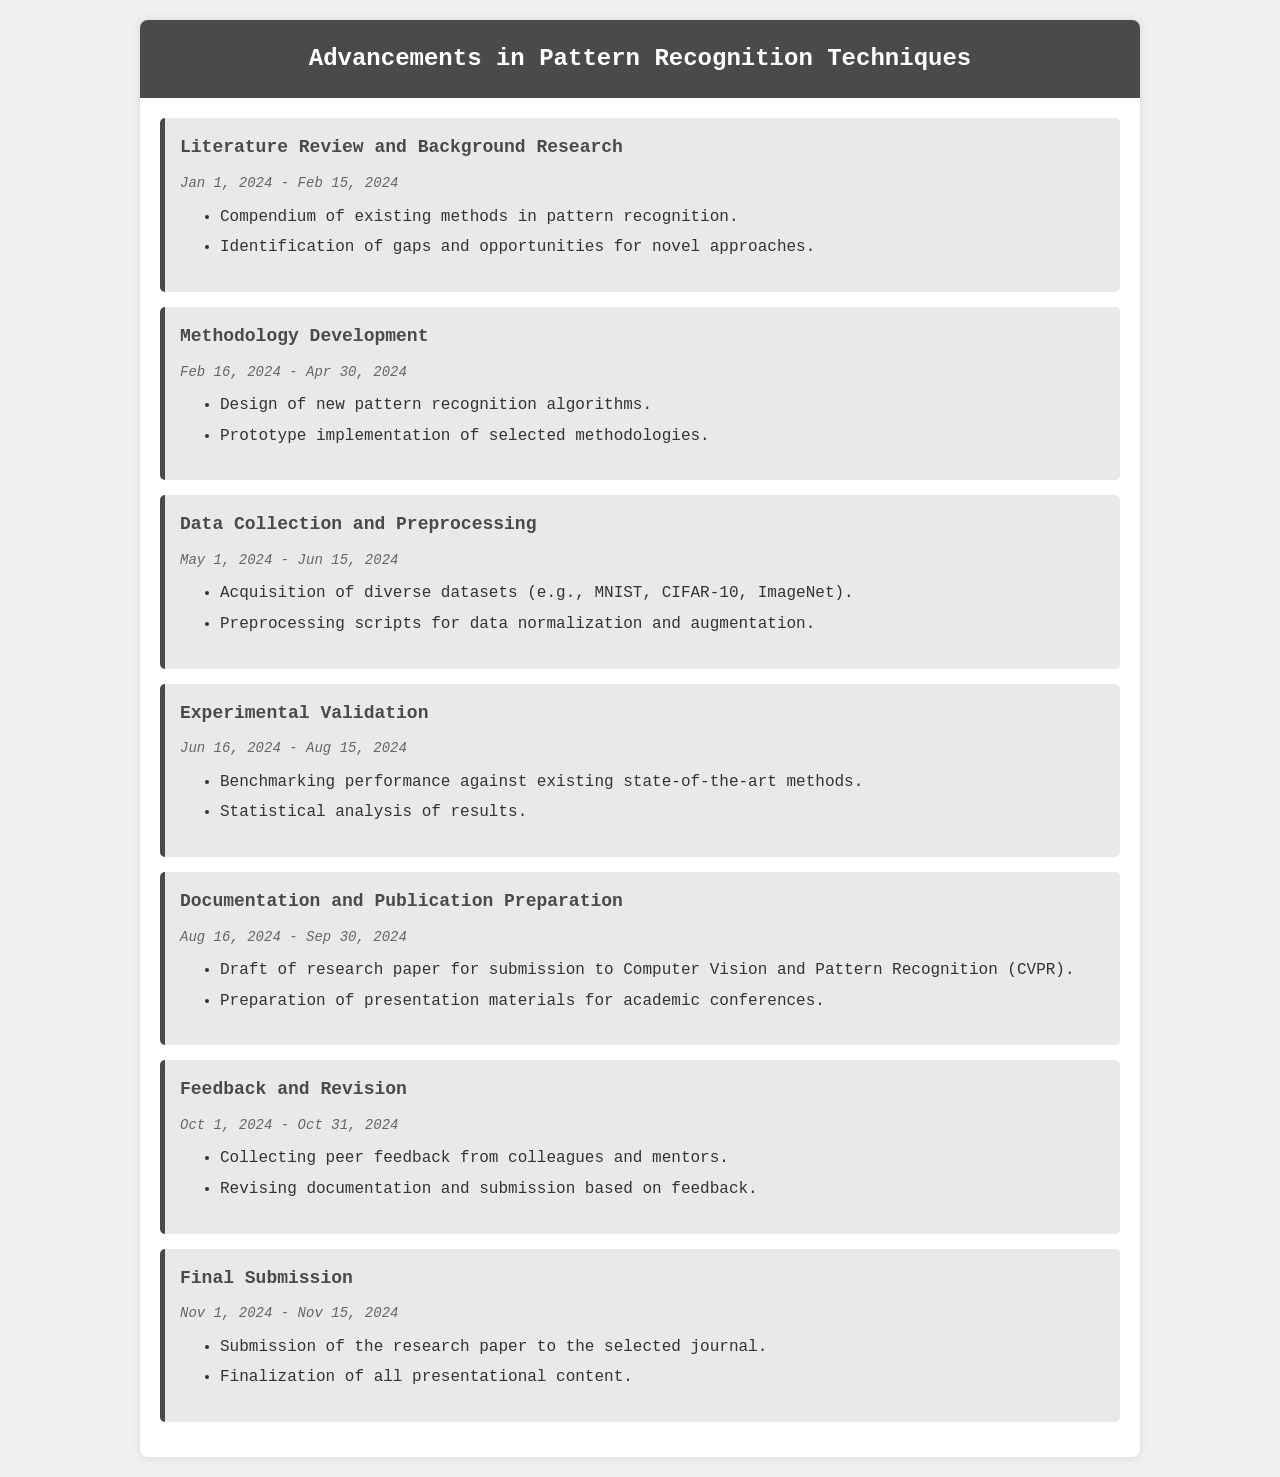What is the title of the project? The title of the project is prominently displayed at the top of the document.
Answer: Advancements in Pattern Recognition Techniques What is the duration of the Literature Review phase? The duration is indicated by the start and end dates shown in that section of the document.
Answer: Jan 1, 2024 - Feb 15, 2024 What is a key deliverable from the Methodology Development phase? The deliverables are listed under each phase, with the specific deliverable highlighted in the Methodology Development section.
Answer: Design of new pattern recognition algorithms When does the Experimental Validation phase start? The start date is stated in the Experimental Validation section of the document.
Answer: Jun 16, 2024 How many total phases are detailed in the document? The total number of phases can be counted from the number of sections listed in the timeline.
Answer: 6 What is the end date of the Feedback and Revision phase? The end date is mentioned in the Feedback and Revision section of the document.
Answer: Oct 31, 2024 Which journal is the research paper to be submitted to? The targeted journal for submission is specified in the Documentation and Publication Preparation phase.
Answer: Computer Vision and Pattern Recognition (CVPR) What type of feedback is collected during the Feedback and Revision phase? The nature of the feedback is described within the deliverables listed in that phase.
Answer: Peer feedback 